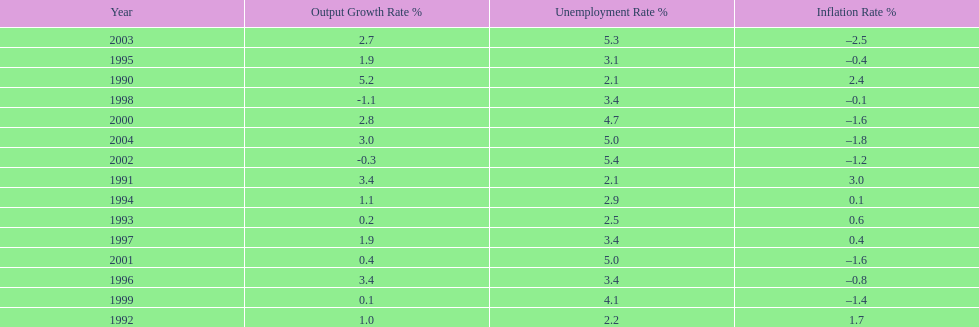What year saw the highest output growth rate in japan between the years 1990 and 2004? 1990. 